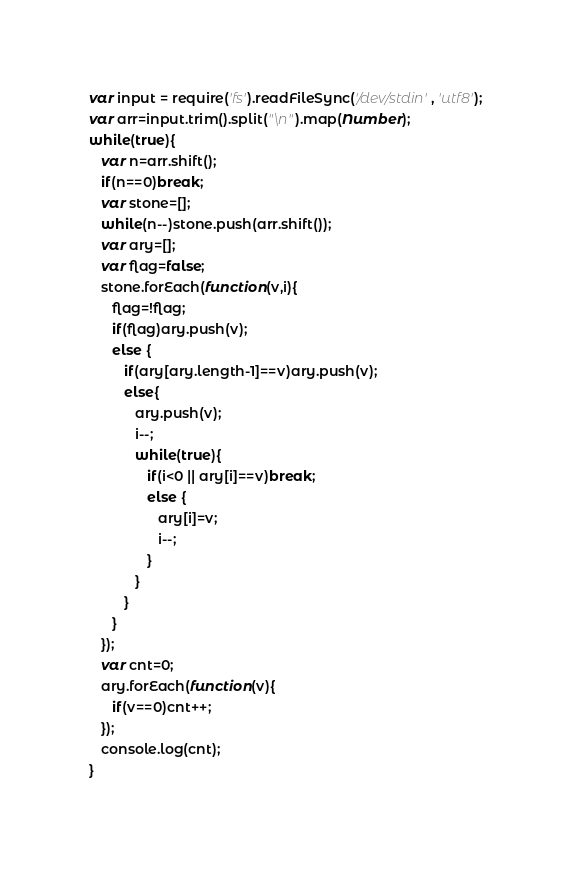Convert code to text. <code><loc_0><loc_0><loc_500><loc_500><_JavaScript_>var input = require('fs').readFileSync('/dev/stdin', 'utf8');
var arr=input.trim().split("\n").map(Number);
while(true){
   var n=arr.shift();
   if(n==0)break;
   var stone=[];
   while(n--)stone.push(arr.shift());
   var ary=[];
   var flag=false;
   stone.forEach(function(v,i){
      flag=!flag;
      if(flag)ary.push(v);
      else {
         if(ary[ary.length-1]==v)ary.push(v);
         else{
            ary.push(v);
            i--;
            while(true){
               if(i<0 || ary[i]==v)break;
               else {
                  ary[i]=v;
                  i--;
               }
            }
         }
      }
   });
   var cnt=0;
   ary.forEach(function(v){
      if(v==0)cnt++;
   });
   console.log(cnt);
}</code> 